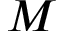Convert formula to latex. <formula><loc_0><loc_0><loc_500><loc_500>M</formula> 